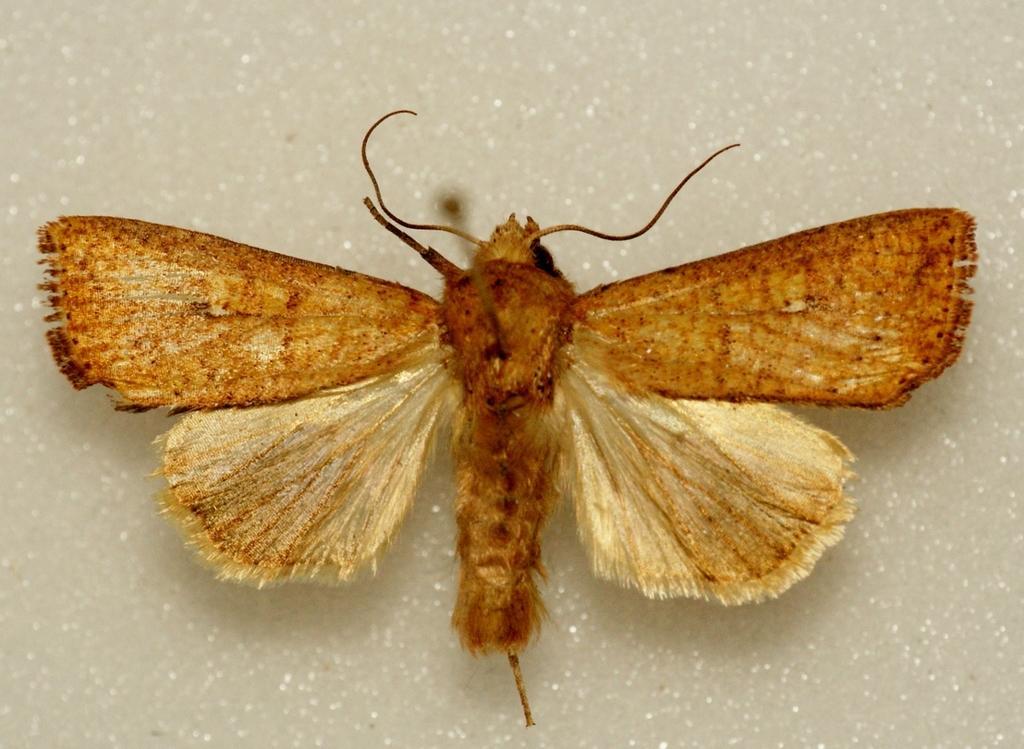Please provide a concise description of this image. In this image we can see a butterfly on the surface. 